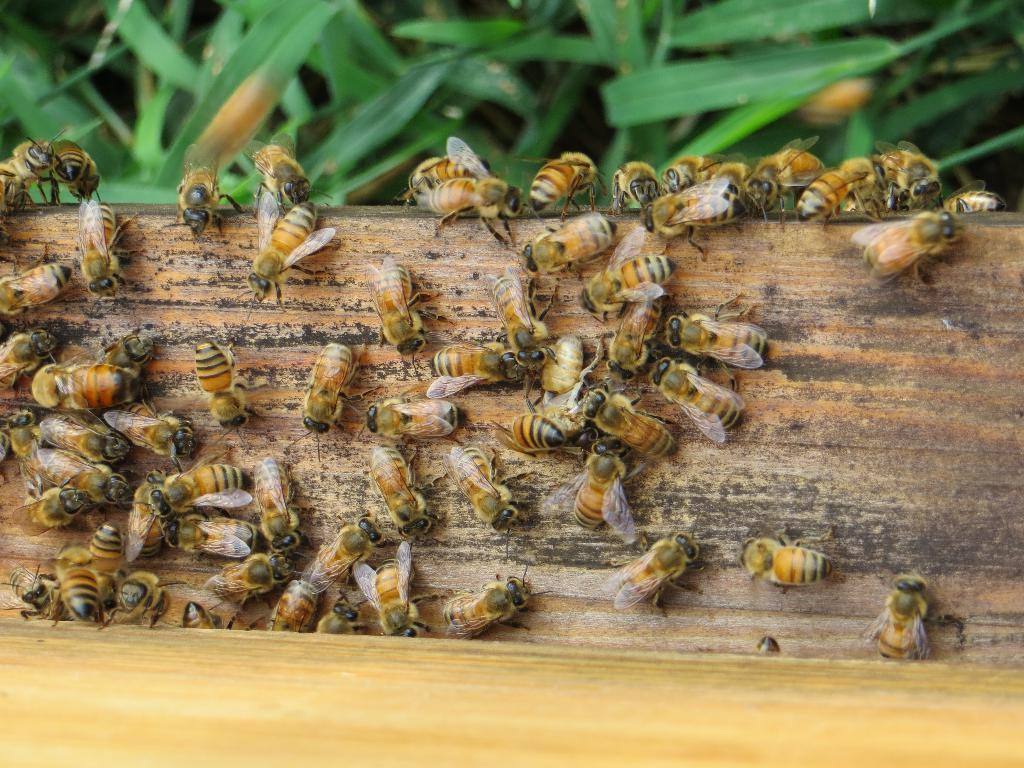What type of insects can be seen in the image? There are honey bees present on wood in the image. What is the location of the honey bees in the image? The honey bees are on wood in the image. What else can be seen in the image besides the honey bees? There are plants visible at the top of the image. Can you tell me how much money is being exchanged between the honey bees in the image? There is no money being exchanged between the honey bees in the image, as they are insects and do not use currency. Is there a river visible in the image? There is no river present in the image; it features honey bees on wood and plants at the top. 